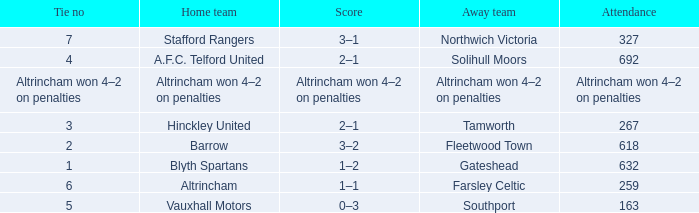Which home team had the away team Southport? Vauxhall Motors. 